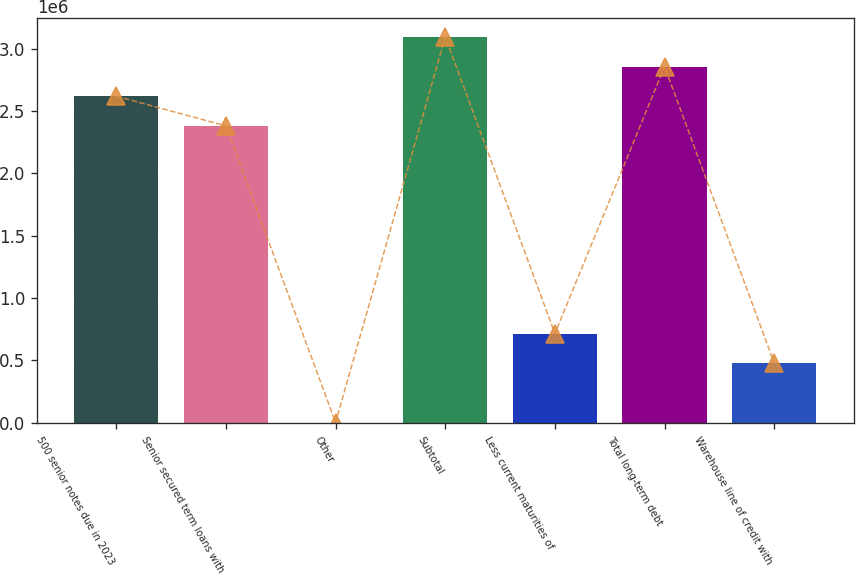Convert chart. <chart><loc_0><loc_0><loc_500><loc_500><bar_chart><fcel>500 senior notes due in 2023<fcel>Senior secured term loans with<fcel>Other<fcel>Subtotal<fcel>Less current maturities of<fcel>Total long-term debt<fcel>Warehouse line of credit with<nl><fcel>2.61911e+06<fcel>2.38126e+06<fcel>2783<fcel>3.0948e+06<fcel>716326<fcel>2.85695e+06<fcel>478478<nl></chart> 